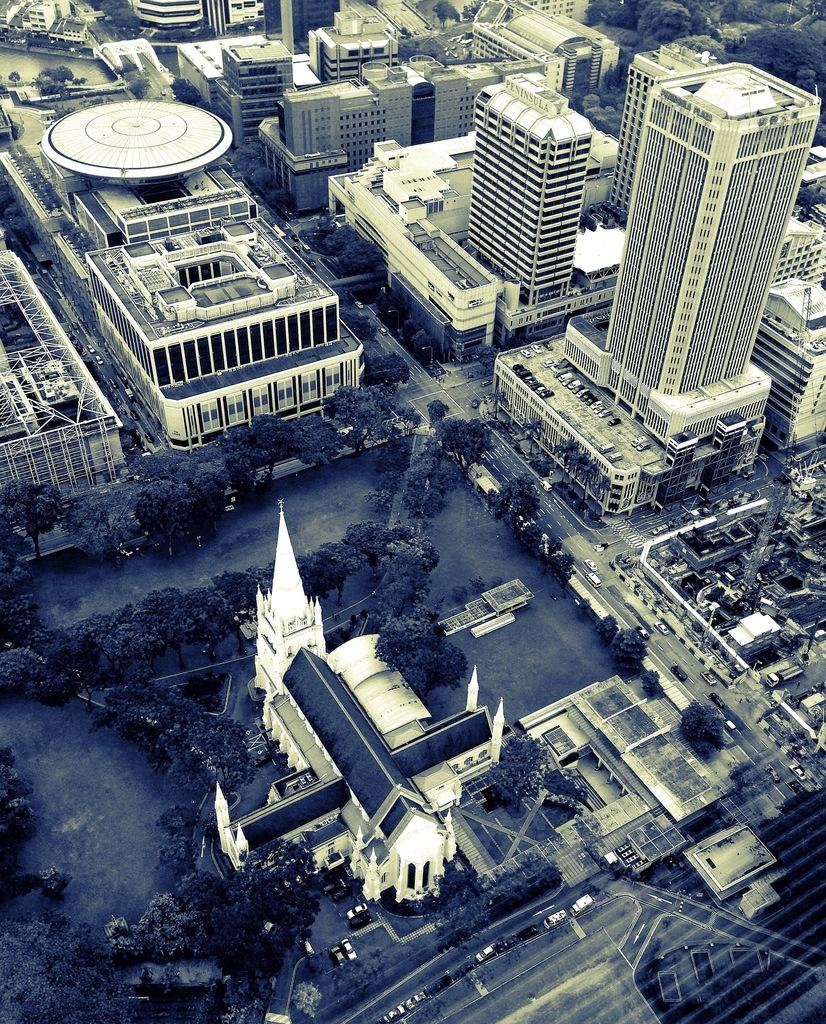What type of structures can be seen in the image? There are buildings and skyscrapers in the image. What can be seen on the road in the image? There are motor vehicles on the road in the image. Where are some of the motor vehicles located in the image? There are motor vehicles in parking slots in the image. What type of vegetation is present in the image? There are trees in the image. What is visible beneath the buildings and trees in the image? There is ground visible in the image. What are the poles used for in the image? The purpose of the poles in the image is not specified, but they are likely used for supporting wires or other infrastructure. What type of knowledge is being shared between the trees in the image? There is no indication in the image that the trees are sharing knowledge or engaging in any form of communication. 